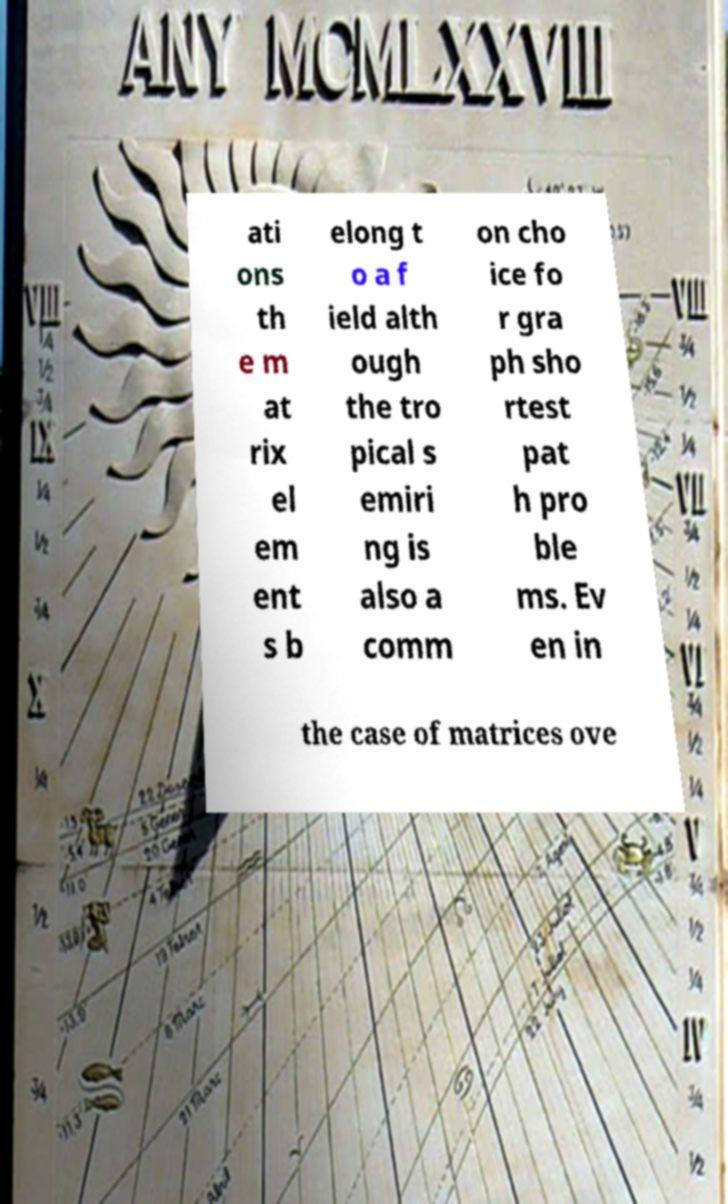Can you read and provide the text displayed in the image?This photo seems to have some interesting text. Can you extract and type it out for me? ati ons th e m at rix el em ent s b elong t o a f ield alth ough the tro pical s emiri ng is also a comm on cho ice fo r gra ph sho rtest pat h pro ble ms. Ev en in the case of matrices ove 